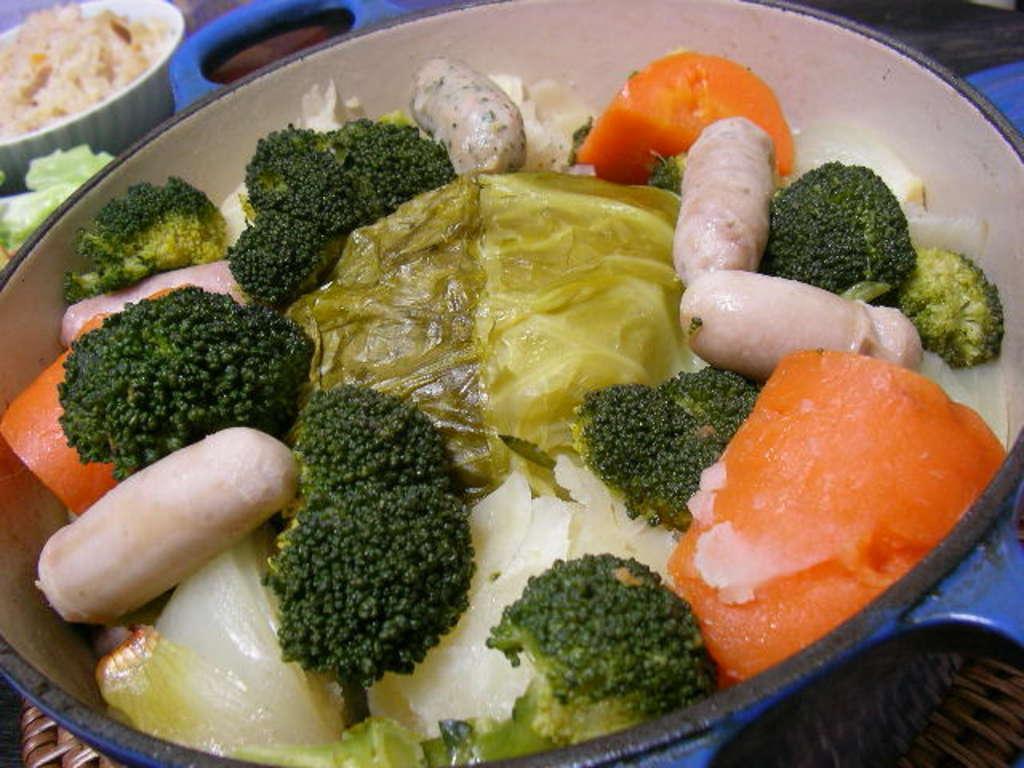Can you describe this image briefly? As we can see in the image there is a table. On table there are bowls. In bowls there are different types of dishes. 